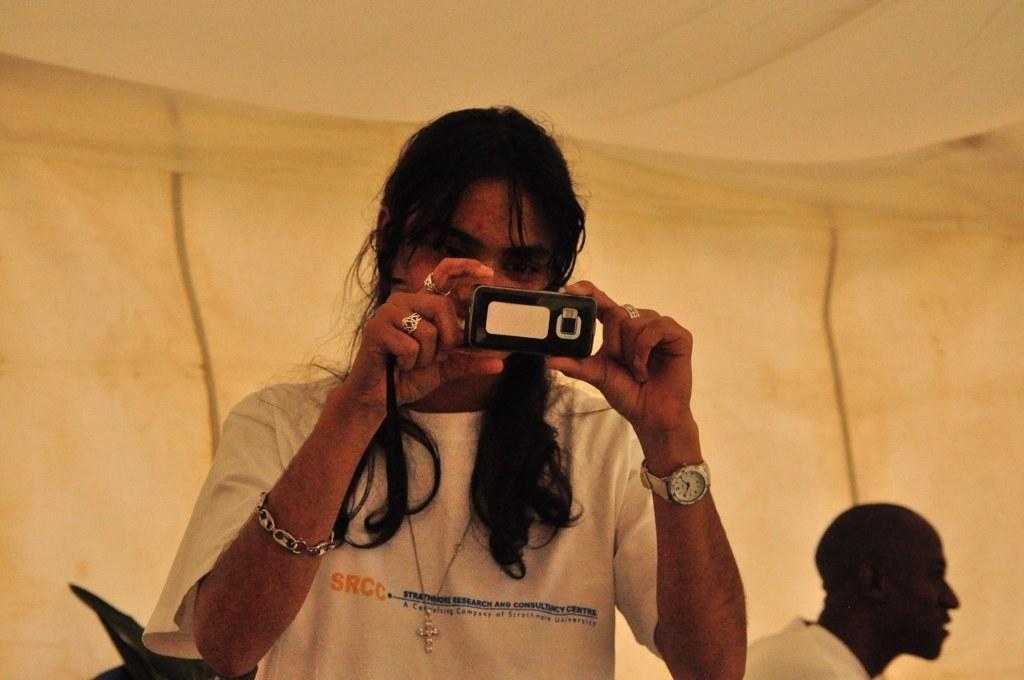How would you summarize this image in a sentence or two? In this picture a man is holding a phone. He is wearing a white t shirt. He is having long black hair. He is wearing watch,bracelet,rings. Beside him there is another person. I think they are inside a tent. 